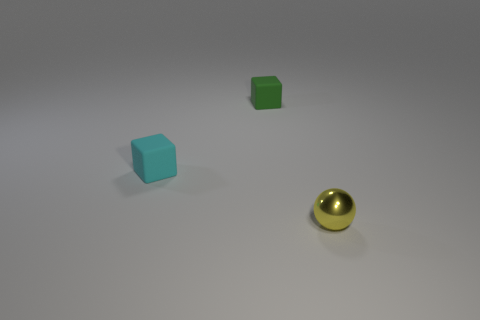Is the number of small blocks less than the number of small objects?
Keep it short and to the point. Yes. Are there any metal objects that are right of the matte object that is behind the tiny thing that is left of the green object?
Your response must be concise. Yes. There is a object that is in front of the cyan object; is its shape the same as the tiny cyan rubber thing?
Your answer should be compact. No. Are there more rubber cubes that are behind the tiny cyan rubber block than red shiny cylinders?
Offer a very short reply. Yes. Do the tiny matte thing in front of the tiny green matte block and the sphere have the same color?
Ensure brevity in your answer.  No. Is there anything else that is the same color as the metallic ball?
Give a very brief answer. No. There is a small cube that is on the left side of the green rubber cube behind the matte cube that is in front of the small green cube; what is its color?
Offer a very short reply. Cyan. Is the size of the green rubber object the same as the cyan thing?
Provide a short and direct response. Yes. How many yellow metallic objects are the same size as the cyan object?
Provide a succinct answer. 1. Does the block in front of the small green cube have the same material as the thing that is on the right side of the green matte object?
Your response must be concise. No. 